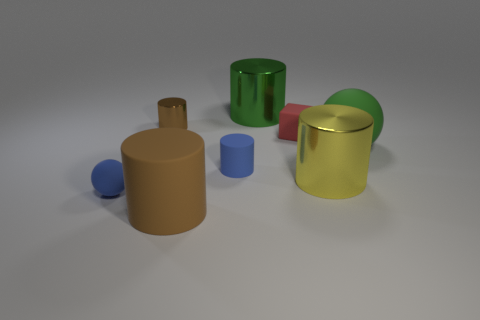Subtract all blue cylinders. How many cylinders are left? 4 Subtract all small blue cylinders. How many cylinders are left? 4 Subtract all blue cylinders. Subtract all green cubes. How many cylinders are left? 4 Add 1 tiny matte spheres. How many objects exist? 9 Subtract all cubes. How many objects are left? 7 Add 8 matte cubes. How many matte cubes are left? 9 Add 7 cyan shiny balls. How many cyan shiny balls exist? 7 Subtract 0 gray blocks. How many objects are left? 8 Subtract all purple cubes. Subtract all metal cylinders. How many objects are left? 5 